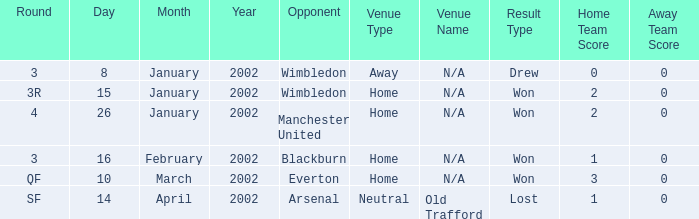What is the Venue with a Date with 14 april 2002? Old Trafford. 